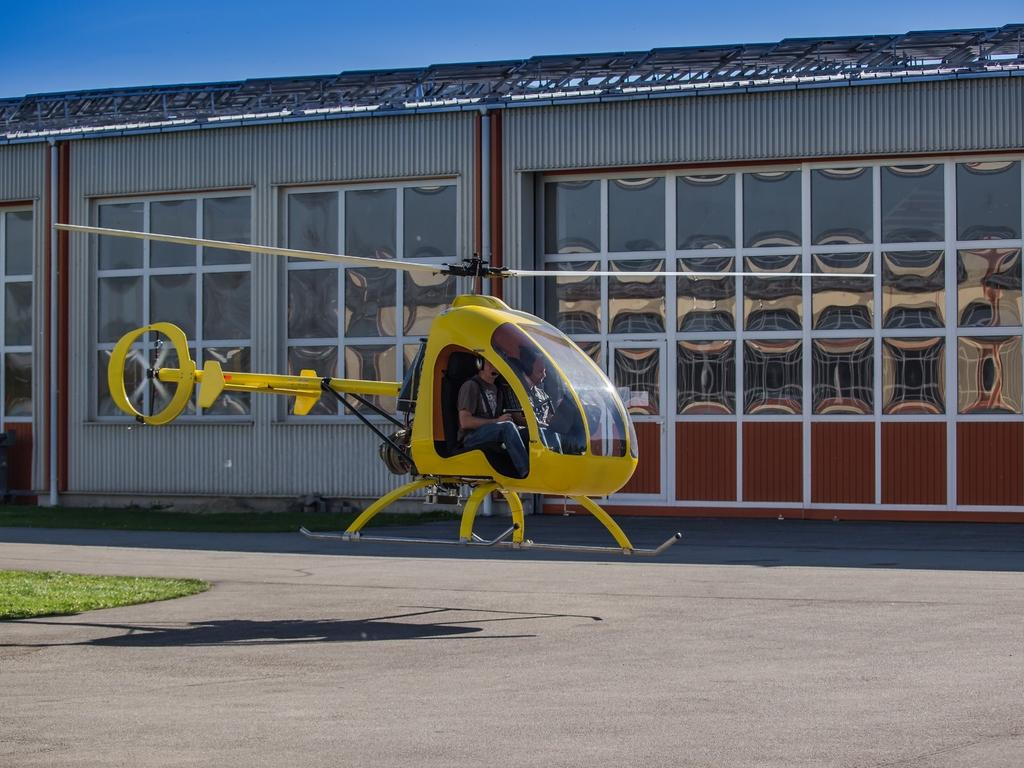What is in the foreground of the image? There is grass and a helicopter in the air in the foreground of the image. What can be seen in the background of the image? There is a building, windows, and the sky visible in the background of the image. Can you describe the helicopter in the image? The helicopter is in the air in the foreground of the image. What might be the time of day when the image was taken? The image might have been taken during the day, as the sky is visible and there is no indication of darkness. What type of nerve can be seen in the image? There is no nerve present in the image; it features grass, a helicopter, a building, windows, and the sky. What is the taste of the helicopter in the image? The helicopter is not a food item and therefore cannot be tasted. 